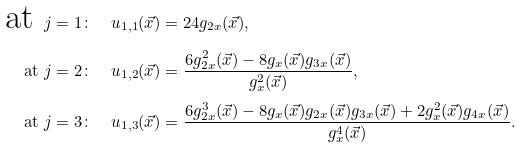Convert formula to latex. <formula><loc_0><loc_0><loc_500><loc_500>\text {at } j = 1 \colon & \quad u _ { 1 , 1 } ( \vec { x } ) = 2 4 g _ { 2 x } ( \vec { x } ) , \\ \text {at } j = 2 \colon & \quad u _ { 1 , 2 } ( \vec { x } ) = \frac { 6 g _ { 2 x } ^ { 2 } ( \vec { x } ) - 8 g _ { x } ( \vec { x } ) g _ { 3 x } ( \vec { x } ) } { g _ { x } ^ { 2 } ( \vec { x } ) } , \\ \text {at } j = 3 \colon & \quad u _ { 1 , 3 } ( \vec { x } ) = \frac { 6 g _ { 2 x } ^ { 3 } ( \vec { x } ) - 8 g _ { x } ( \vec { x } ) g _ { 2 x } ( \vec { x } ) g _ { 3 x } ( \vec { x } ) + 2 g _ { x } ^ { 2 } ( \vec { x } ) g _ { 4 x } ( \vec { x } ) } { g _ { x } ^ { 4 } ( \vec { x } ) } .</formula> 